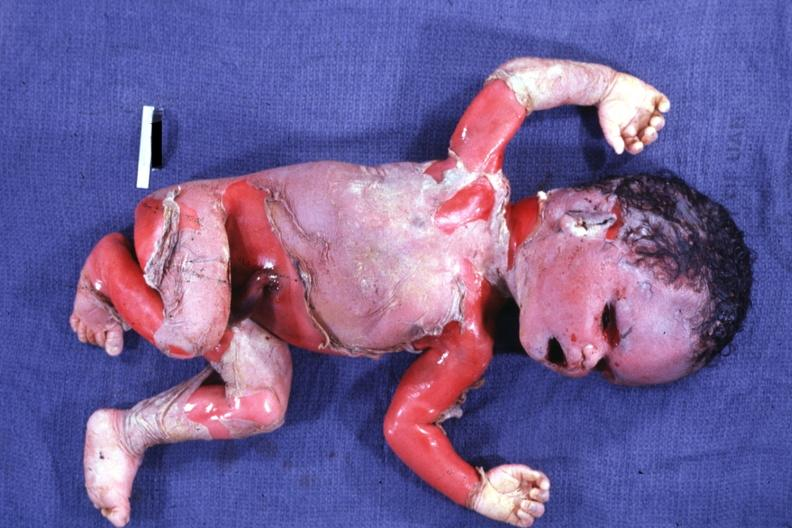does this image show severe maceration?
Answer the question using a single word or phrase. Yes 